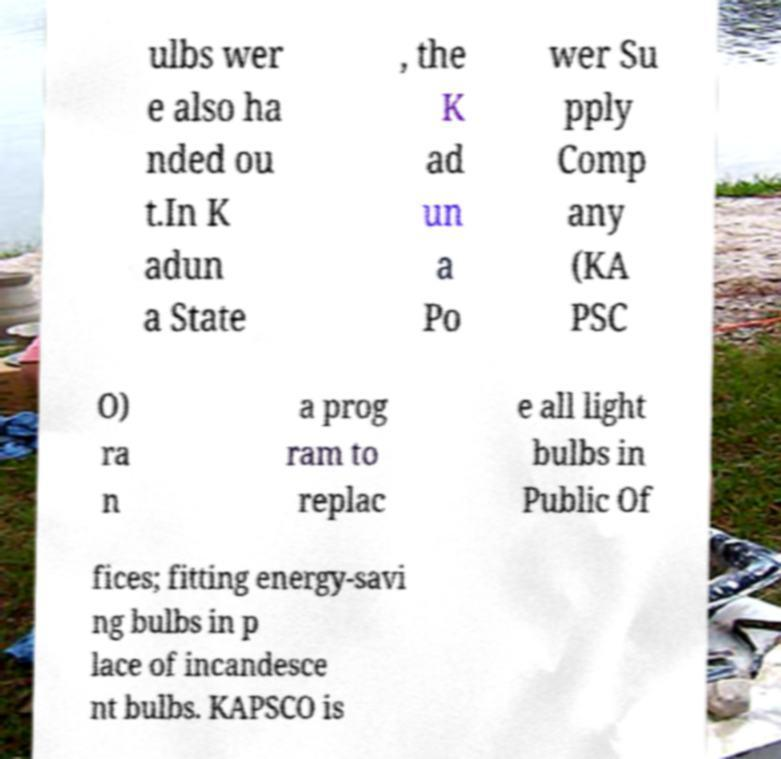Can you accurately transcribe the text from the provided image for me? ulbs wer e also ha nded ou t.In K adun a State , the K ad un a Po wer Su pply Comp any (KA PSC O) ra n a prog ram to replac e all light bulbs in Public Of fices; fitting energy-savi ng bulbs in p lace of incandesce nt bulbs. KAPSCO is 